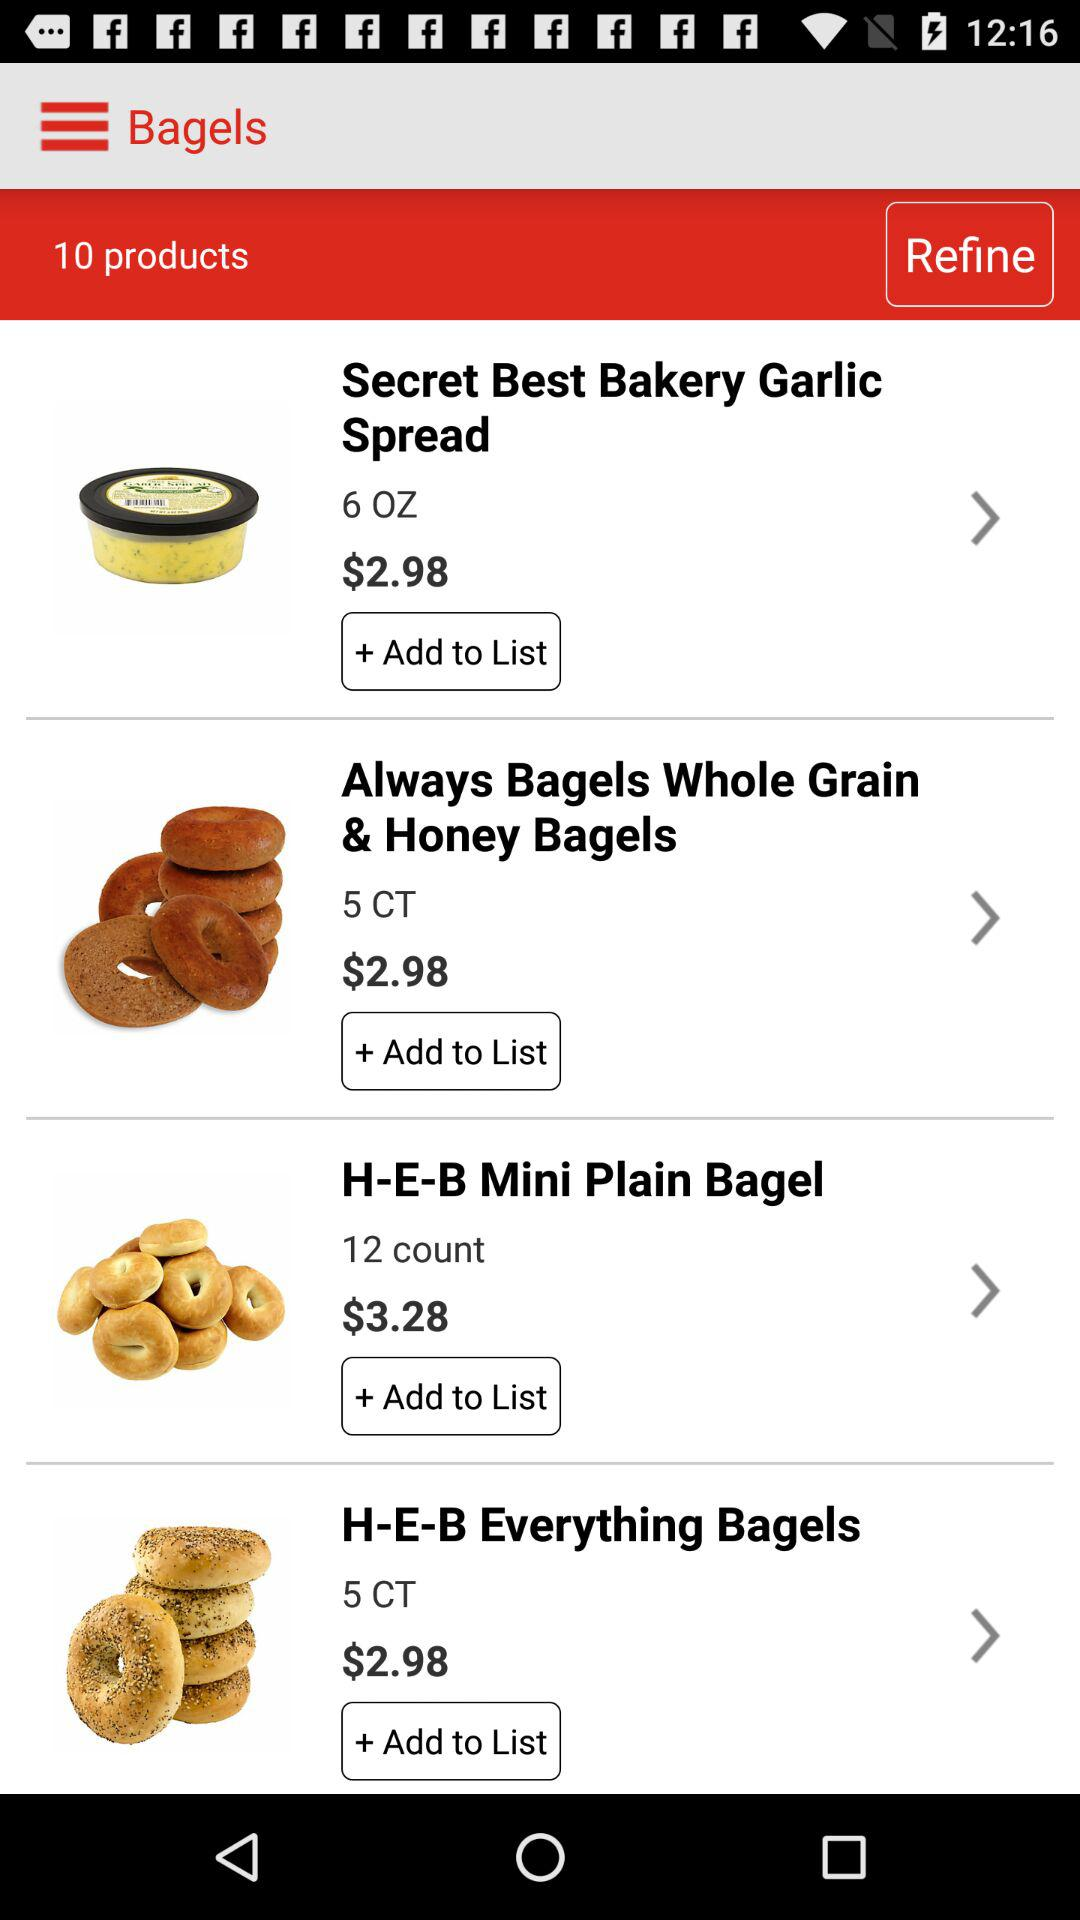How many products are there? There are 10 products. 